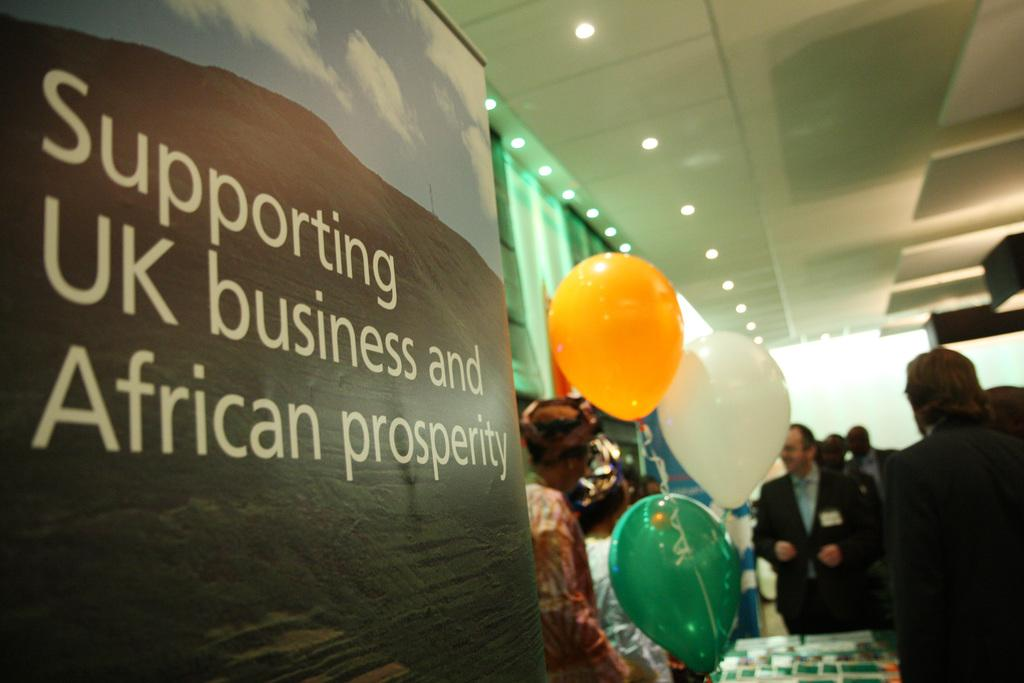What can be seen in the foreground of the picture? There are balloons and a banner in the foreground of the picture. What is located in the center of the picture? There are people and other objects in the center of the picture. Can you describe any features of the room or space in the image? There are lights attached to the ceiling in the image. What type of cars can be seen parked near the seashore in the image? There is no seashore or cars present in the image; it features balloons, a banner, people, and lights in a room. 